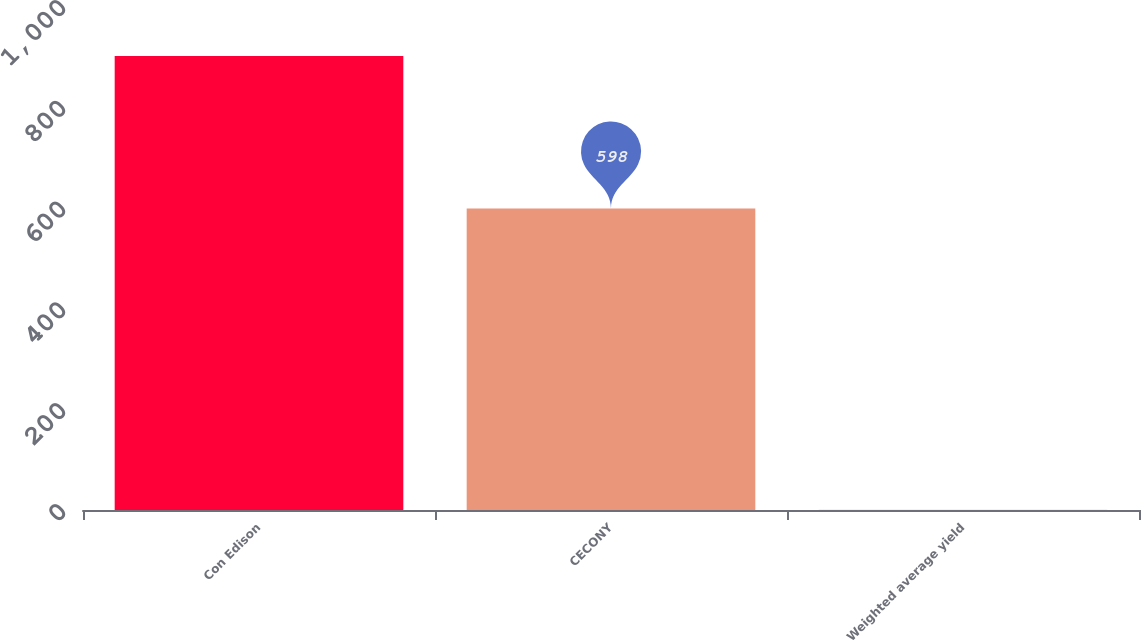<chart> <loc_0><loc_0><loc_500><loc_500><bar_chart><fcel>Con Edison<fcel>CECONY<fcel>Weighted average yield<nl><fcel>901<fcel>598<fcel>0.3<nl></chart> 